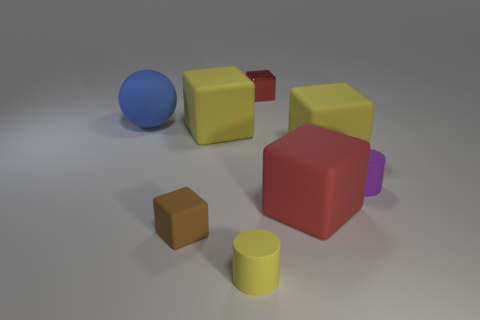Subtract all brown blocks. How many blocks are left? 4 Subtract all red shiny cubes. How many cubes are left? 4 Subtract 2 cubes. How many cubes are left? 3 Subtract all gray blocks. Subtract all yellow spheres. How many blocks are left? 5 Add 1 tiny yellow cylinders. How many objects exist? 9 Subtract all cubes. How many objects are left? 3 Add 3 big gray rubber cylinders. How many big gray rubber cylinders exist? 3 Subtract 0 blue cylinders. How many objects are left? 8 Subtract all brown matte objects. Subtract all blue cylinders. How many objects are left? 7 Add 7 spheres. How many spheres are left? 8 